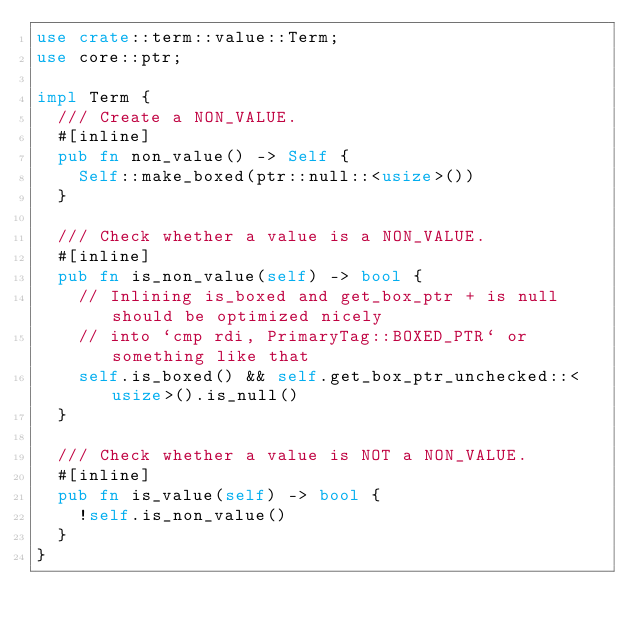<code> <loc_0><loc_0><loc_500><loc_500><_Rust_>use crate::term::value::Term;
use core::ptr;

impl Term {
  /// Create a NON_VALUE.
  #[inline]
  pub fn non_value() -> Self {
    Self::make_boxed(ptr::null::<usize>())
  }

  /// Check whether a value is a NON_VALUE.
  #[inline]
  pub fn is_non_value(self) -> bool {
    // Inlining is_boxed and get_box_ptr + is null should be optimized nicely
    // into `cmp rdi, PrimaryTag::BOXED_PTR` or something like that
    self.is_boxed() && self.get_box_ptr_unchecked::<usize>().is_null()
  }

  /// Check whether a value is NOT a NON_VALUE.
  #[inline]
  pub fn is_value(self) -> bool {
    !self.is_non_value()
  }
}
</code> 